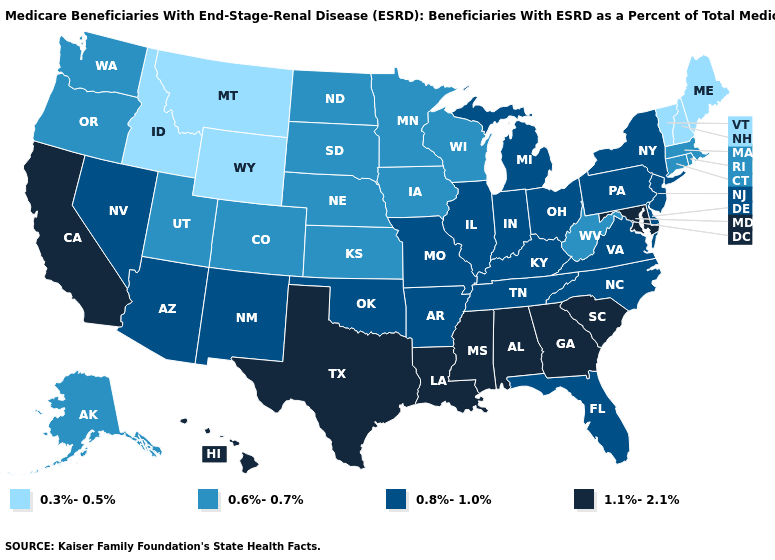What is the value of Washington?
Concise answer only. 0.6%-0.7%. Among the states that border Alabama , which have the lowest value?
Quick response, please. Florida, Tennessee. Name the states that have a value in the range 0.6%-0.7%?
Write a very short answer. Alaska, Colorado, Connecticut, Iowa, Kansas, Massachusetts, Minnesota, Nebraska, North Dakota, Oregon, Rhode Island, South Dakota, Utah, Washington, West Virginia, Wisconsin. What is the value of Arizona?
Be succinct. 0.8%-1.0%. What is the lowest value in the MidWest?
Concise answer only. 0.6%-0.7%. Name the states that have a value in the range 1.1%-2.1%?
Short answer required. Alabama, California, Georgia, Hawaii, Louisiana, Maryland, Mississippi, South Carolina, Texas. Name the states that have a value in the range 0.3%-0.5%?
Write a very short answer. Idaho, Maine, Montana, New Hampshire, Vermont, Wyoming. Name the states that have a value in the range 0.8%-1.0%?
Be succinct. Arizona, Arkansas, Delaware, Florida, Illinois, Indiana, Kentucky, Michigan, Missouri, Nevada, New Jersey, New Mexico, New York, North Carolina, Ohio, Oklahoma, Pennsylvania, Tennessee, Virginia. How many symbols are there in the legend?
Quick response, please. 4. Name the states that have a value in the range 0.8%-1.0%?
Write a very short answer. Arizona, Arkansas, Delaware, Florida, Illinois, Indiana, Kentucky, Michigan, Missouri, Nevada, New Jersey, New Mexico, New York, North Carolina, Ohio, Oklahoma, Pennsylvania, Tennessee, Virginia. What is the highest value in states that border Mississippi?
Give a very brief answer. 1.1%-2.1%. What is the value of Virginia?
Give a very brief answer. 0.8%-1.0%. Does Montana have the lowest value in the West?
Short answer required. Yes. Among the states that border California , which have the highest value?
Quick response, please. Arizona, Nevada. Name the states that have a value in the range 0.8%-1.0%?
Be succinct. Arizona, Arkansas, Delaware, Florida, Illinois, Indiana, Kentucky, Michigan, Missouri, Nevada, New Jersey, New Mexico, New York, North Carolina, Ohio, Oklahoma, Pennsylvania, Tennessee, Virginia. 